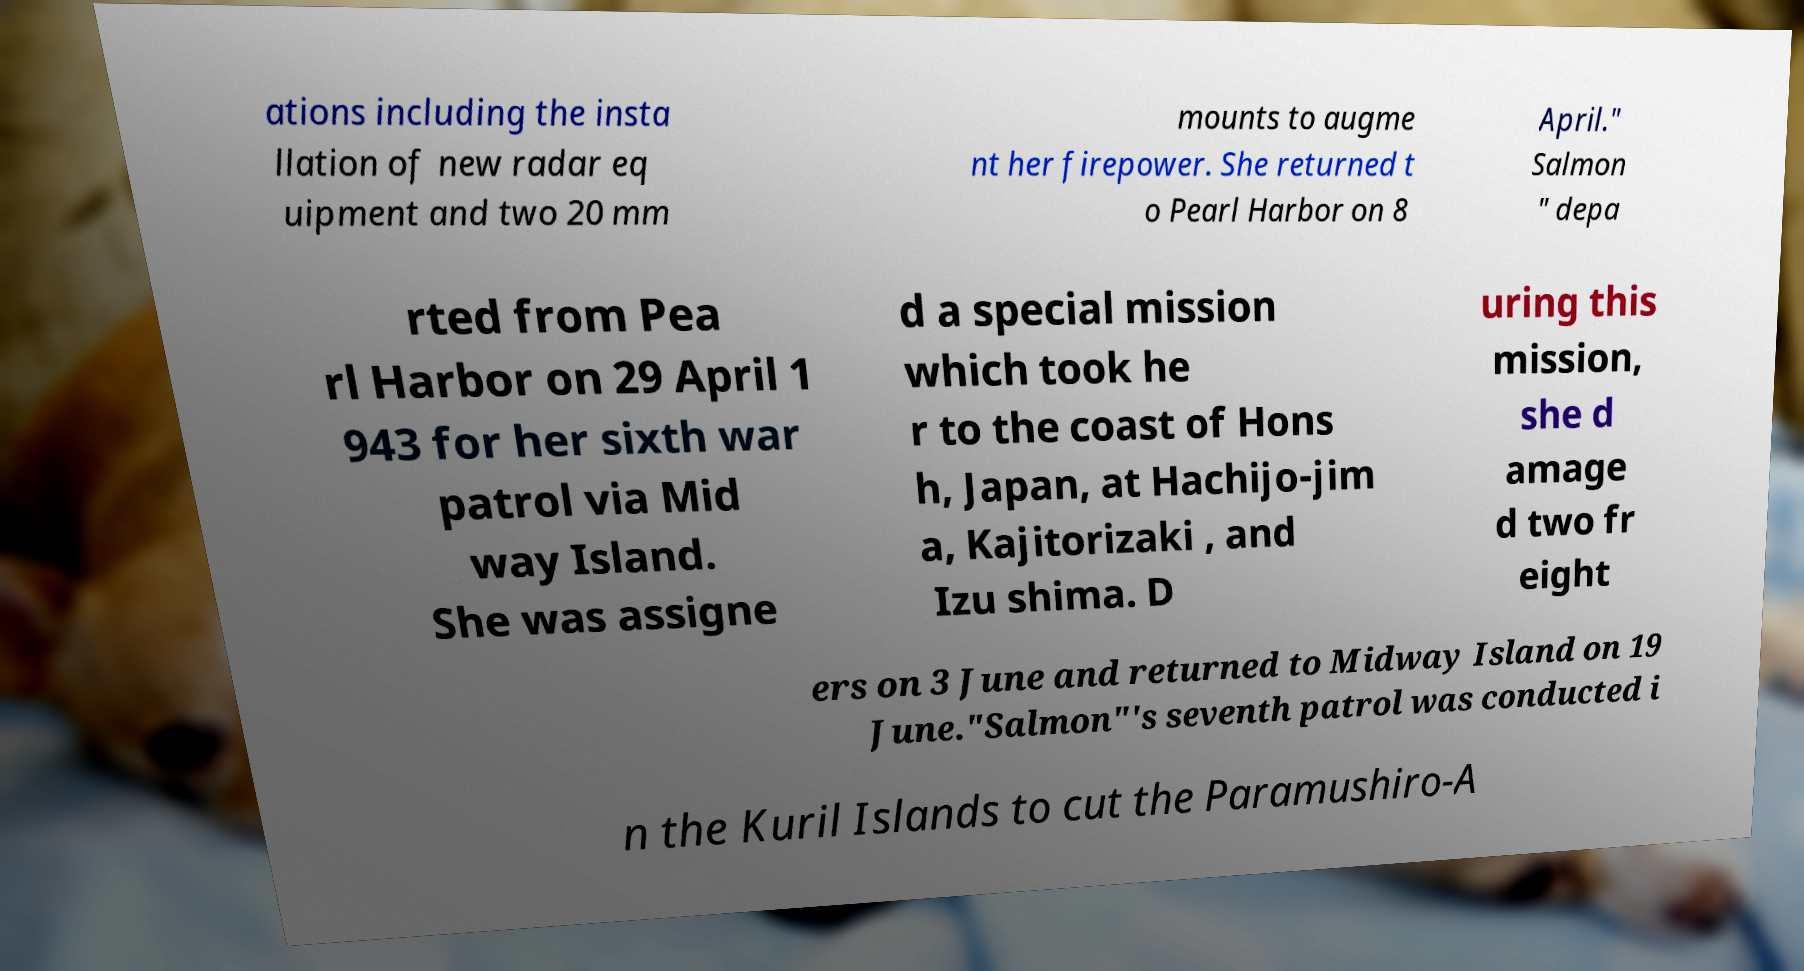Can you read and provide the text displayed in the image?This photo seems to have some interesting text. Can you extract and type it out for me? ations including the insta llation of new radar eq uipment and two 20 mm mounts to augme nt her firepower. She returned t o Pearl Harbor on 8 April." Salmon " depa rted from Pea rl Harbor on 29 April 1 943 for her sixth war patrol via Mid way Island. She was assigne d a special mission which took he r to the coast of Hons h, Japan, at Hachijo-jim a, Kajitorizaki , and Izu shima. D uring this mission, she d amage d two fr eight ers on 3 June and returned to Midway Island on 19 June."Salmon"'s seventh patrol was conducted i n the Kuril Islands to cut the Paramushiro-A 